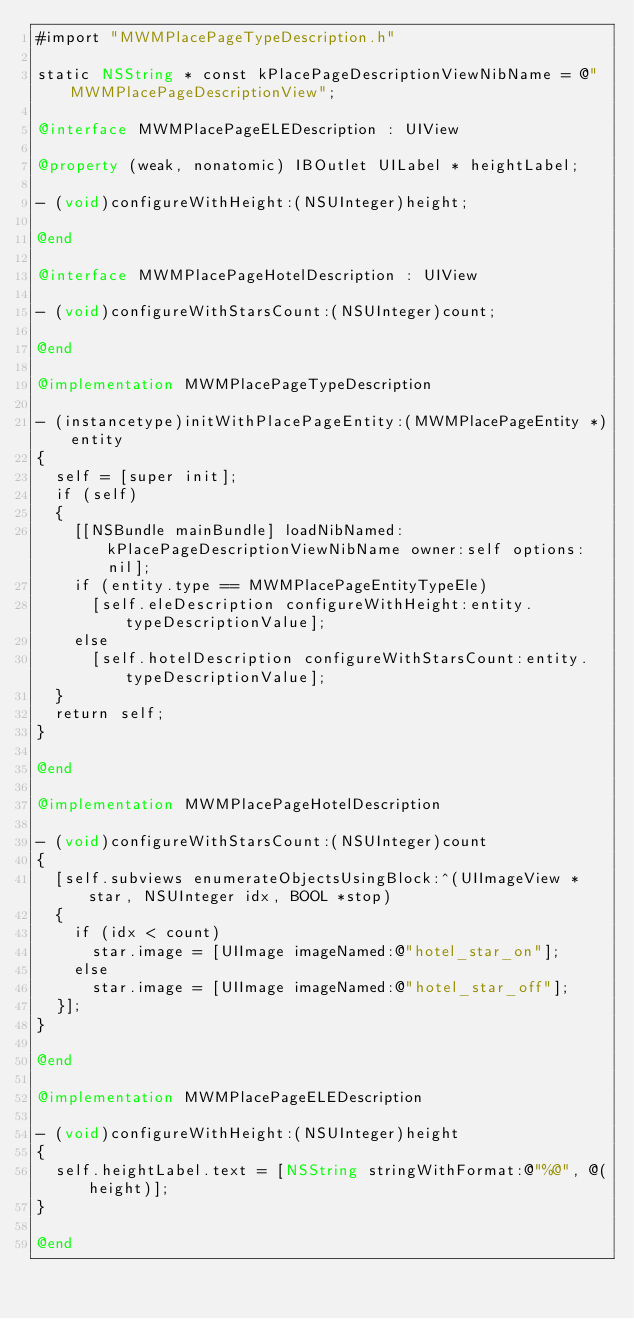Convert code to text. <code><loc_0><loc_0><loc_500><loc_500><_ObjectiveC_>#import "MWMPlacePageTypeDescription.h"

static NSString * const kPlacePageDescriptionViewNibName = @"MWMPlacePageDescriptionView";

@interface MWMPlacePageELEDescription : UIView

@property (weak, nonatomic) IBOutlet UILabel * heightLabel;

- (void)configureWithHeight:(NSUInteger)height;

@end

@interface MWMPlacePageHotelDescription : UIView

- (void)configureWithStarsCount:(NSUInteger)count;

@end

@implementation MWMPlacePageTypeDescription

- (instancetype)initWithPlacePageEntity:(MWMPlacePageEntity *)entity
{
  self = [super init];
  if (self)
  {
    [[NSBundle mainBundle] loadNibNamed:kPlacePageDescriptionViewNibName owner:self options:nil];
    if (entity.type == MWMPlacePageEntityTypeEle)
      [self.eleDescription configureWithHeight:entity.typeDescriptionValue];
    else
      [self.hotelDescription configureWithStarsCount:entity.typeDescriptionValue];
  }
  return self;
}

@end

@implementation MWMPlacePageHotelDescription

- (void)configureWithStarsCount:(NSUInteger)count
{
  [self.subviews enumerateObjectsUsingBlock:^(UIImageView * star, NSUInteger idx, BOOL *stop)
  {
    if (idx < count)
      star.image = [UIImage imageNamed:@"hotel_star_on"];
    else
      star.image = [UIImage imageNamed:@"hotel_star_off"];
  }];
}

@end

@implementation MWMPlacePageELEDescription

- (void)configureWithHeight:(NSUInteger)height
{
  self.heightLabel.text = [NSString stringWithFormat:@"%@", @(height)];
}

@end

</code> 